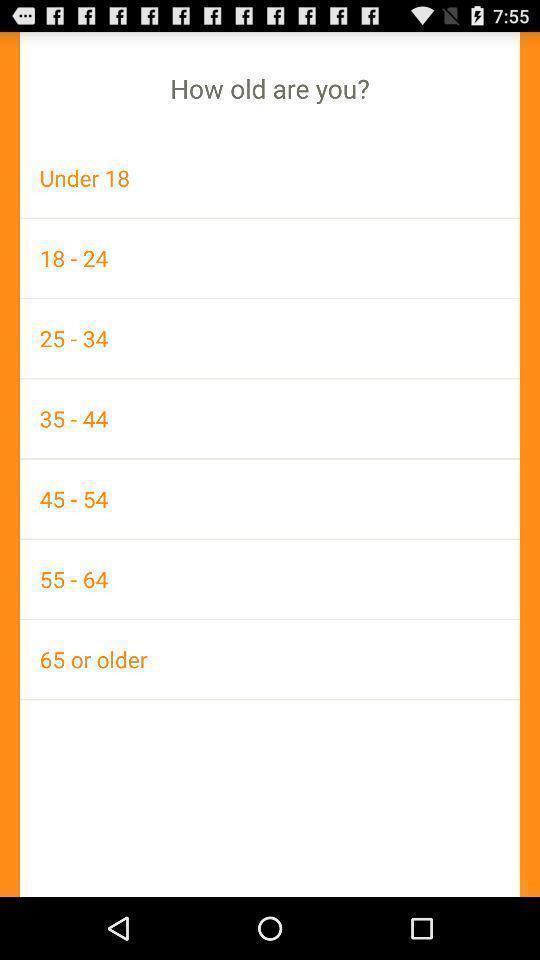Describe the visual elements of this screenshot. Screen showing list of various age groups. 